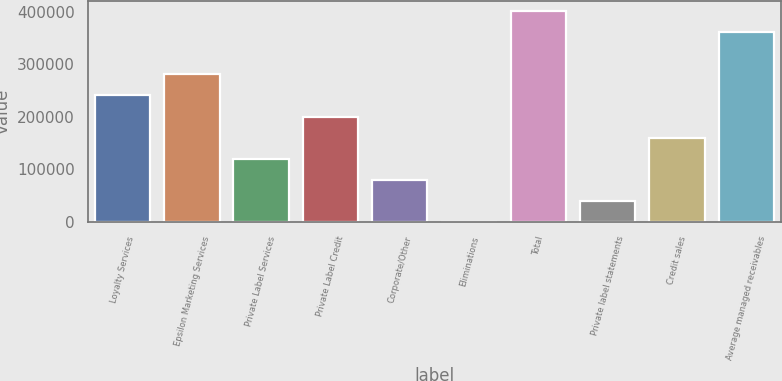Convert chart. <chart><loc_0><loc_0><loc_500><loc_500><bar_chart><fcel>Loyalty Services<fcel>Epsilon Marketing Services<fcel>Private Label Services<fcel>Private Label Credit<fcel>Corporate/Other<fcel>Eliminations<fcel>Total<fcel>Private label statements<fcel>Credit sales<fcel>Average managed receivables<nl><fcel>240860<fcel>280937<fcel>120631<fcel>200784<fcel>80554.8<fcel>402<fcel>401166<fcel>40478.4<fcel>160708<fcel>361090<nl></chart> 